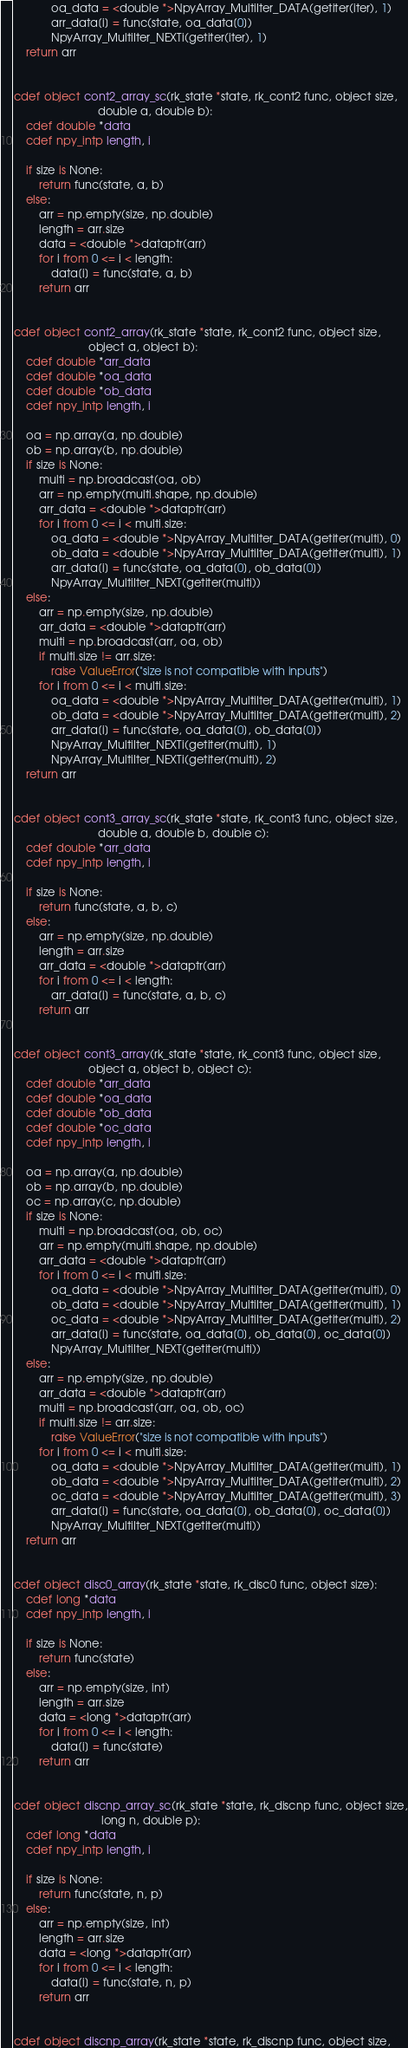<code> <loc_0><loc_0><loc_500><loc_500><_Cython_>            oa_data = <double *>NpyArray_MultiIter_DATA(getiter(iter), 1)
            arr_data[i] = func(state, oa_data[0])
            NpyArray_MultiIter_NEXTi(getiter(iter), 1)
    return arr


cdef object cont2_array_sc(rk_state *state, rk_cont2 func, object size,
                           double a, double b):
    cdef double *data
    cdef npy_intp length, i

    if size is None:
        return func(state, a, b)
    else:
        arr = np.empty(size, np.double)
        length = arr.size
        data = <double *>dataptr(arr)
        for i from 0 <= i < length:
            data[i] = func(state, a, b)
        return arr


cdef object cont2_array(rk_state *state, rk_cont2 func, object size,
                        object a, object b):
    cdef double *arr_data
    cdef double *oa_data
    cdef double *ob_data
    cdef npy_intp length, i

    oa = np.array(a, np.double)
    ob = np.array(b, np.double)
    if size is None:
        multi = np.broadcast(oa, ob)
        arr = np.empty(multi.shape, np.double)
        arr_data = <double *>dataptr(arr)
        for i from 0 <= i < multi.size:
            oa_data = <double *>NpyArray_MultiIter_DATA(getiter(multi), 0)
            ob_data = <double *>NpyArray_MultiIter_DATA(getiter(multi), 1)
            arr_data[i] = func(state, oa_data[0], ob_data[0])
            NpyArray_MultiIter_NEXT(getiter(multi))
    else:
        arr = np.empty(size, np.double)
        arr_data = <double *>dataptr(arr)
        multi = np.broadcast(arr, oa, ob)
        if multi.size != arr.size:
            raise ValueError("size is not compatible with inputs")
        for i from 0 <= i < multi.size:
            oa_data = <double *>NpyArray_MultiIter_DATA(getiter(multi), 1)
            ob_data = <double *>NpyArray_MultiIter_DATA(getiter(multi), 2)
            arr_data[i] = func(state, oa_data[0], ob_data[0])
            NpyArray_MultiIter_NEXTi(getiter(multi), 1)
            NpyArray_MultiIter_NEXTi(getiter(multi), 2)
    return arr


cdef object cont3_array_sc(rk_state *state, rk_cont3 func, object size,
                           double a, double b, double c):
    cdef double *arr_data
    cdef npy_intp length, i

    if size is None:
        return func(state, a, b, c)
    else:
        arr = np.empty(size, np.double)
        length = arr.size
        arr_data = <double *>dataptr(arr)
        for i from 0 <= i < length:
            arr_data[i] = func(state, a, b, c)
        return arr


cdef object cont3_array(rk_state *state, rk_cont3 func, object size,
                        object a, object b, object c):
    cdef double *arr_data
    cdef double *oa_data
    cdef double *ob_data
    cdef double *oc_data
    cdef npy_intp length, i

    oa = np.array(a, np.double)
    ob = np.array(b, np.double)
    oc = np.array(c, np.double)
    if size is None:
        multi = np.broadcast(oa, ob, oc)
        arr = np.empty(multi.shape, np.double)
        arr_data = <double *>dataptr(arr)
        for i from 0 <= i < multi.size:
            oa_data = <double *>NpyArray_MultiIter_DATA(getiter(multi), 0)
            ob_data = <double *>NpyArray_MultiIter_DATA(getiter(multi), 1)
            oc_data = <double *>NpyArray_MultiIter_DATA(getiter(multi), 2)
            arr_data[i] = func(state, oa_data[0], ob_data[0], oc_data[0])
            NpyArray_MultiIter_NEXT(getiter(multi))
    else:
        arr = np.empty(size, np.double)
        arr_data = <double *>dataptr(arr)
        multi = np.broadcast(arr, oa, ob, oc)
        if multi.size != arr.size:
            raise ValueError("size is not compatible with inputs")
        for i from 0 <= i < multi.size:
            oa_data = <double *>NpyArray_MultiIter_DATA(getiter(multi), 1)
            ob_data = <double *>NpyArray_MultiIter_DATA(getiter(multi), 2)
            oc_data = <double *>NpyArray_MultiIter_DATA(getiter(multi), 3)
            arr_data[i] = func(state, oa_data[0], ob_data[0], oc_data[0])
            NpyArray_MultiIter_NEXT(getiter(multi))
    return arr


cdef object disc0_array(rk_state *state, rk_disc0 func, object size):
    cdef long *data
    cdef npy_intp length, i

    if size is None:
        return func(state)
    else:
        arr = np.empty(size, int)
        length = arr.size
        data = <long *>dataptr(arr)
        for i from 0 <= i < length:
            data[i] = func(state)
        return arr


cdef object discnp_array_sc(rk_state *state, rk_discnp func, object size,
                            long n, double p):
    cdef long *data
    cdef npy_intp length, i

    if size is None:
        return func(state, n, p)
    else:
        arr = np.empty(size, int)
        length = arr.size
        data = <long *>dataptr(arr)
        for i from 0 <= i < length:
            data[i] = func(state, n, p)
        return arr


cdef object discnp_array(rk_state *state, rk_discnp func, object size,</code> 